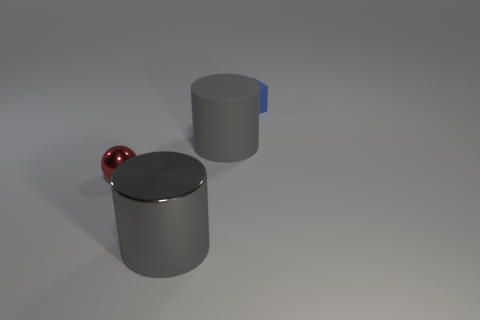Add 1 shiny cylinders. How many objects exist? 5 Subtract all blocks. How many objects are left? 3 Add 4 large green rubber cubes. How many large green rubber cubes exist? 4 Subtract 0 yellow cylinders. How many objects are left? 4 Subtract all big yellow rubber things. Subtract all metal balls. How many objects are left? 3 Add 1 blocks. How many blocks are left? 2 